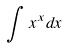<formula> <loc_0><loc_0><loc_500><loc_500>\int x ^ { x } d x</formula> 